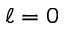Convert formula to latex. <formula><loc_0><loc_0><loc_500><loc_500>\ell = 0</formula> 